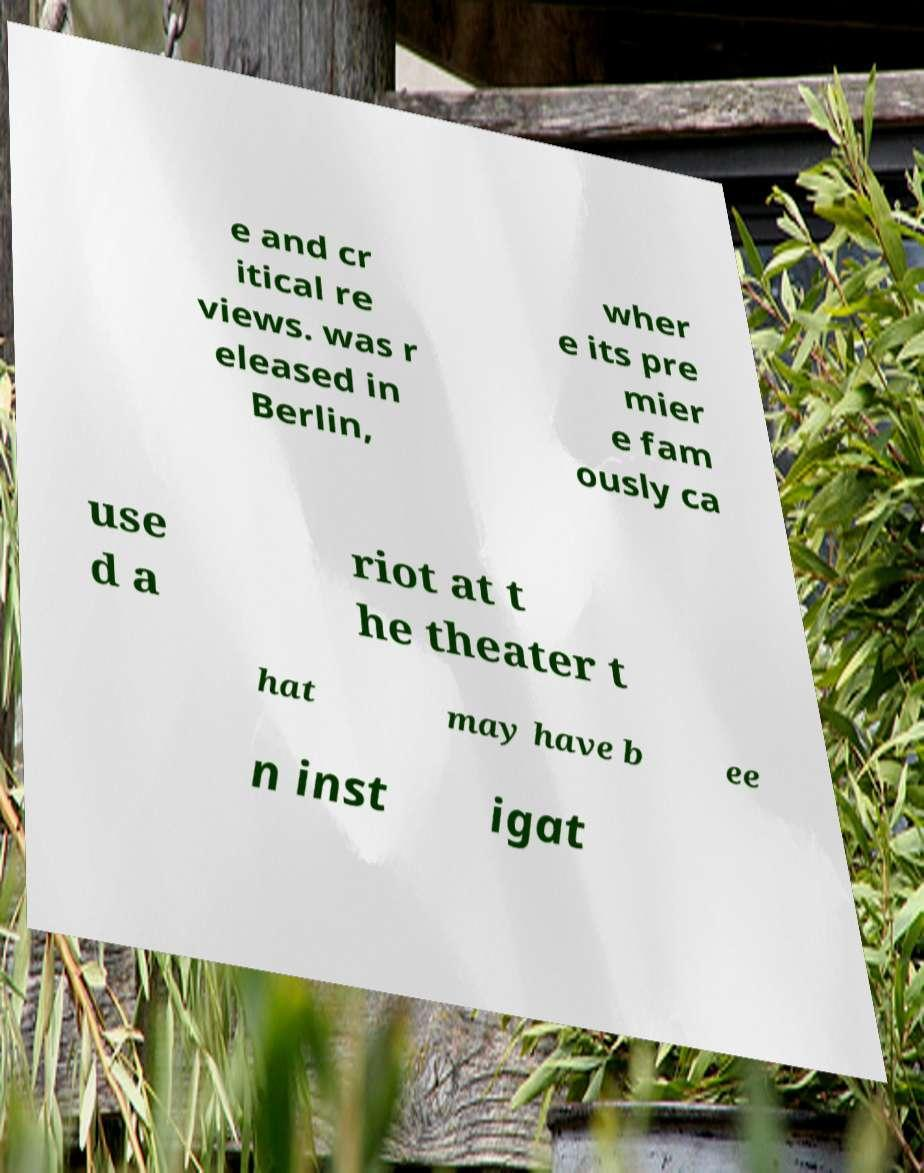Could you assist in decoding the text presented in this image and type it out clearly? e and cr itical re views. was r eleased in Berlin, wher e its pre mier e fam ously ca use d a riot at t he theater t hat may have b ee n inst igat 